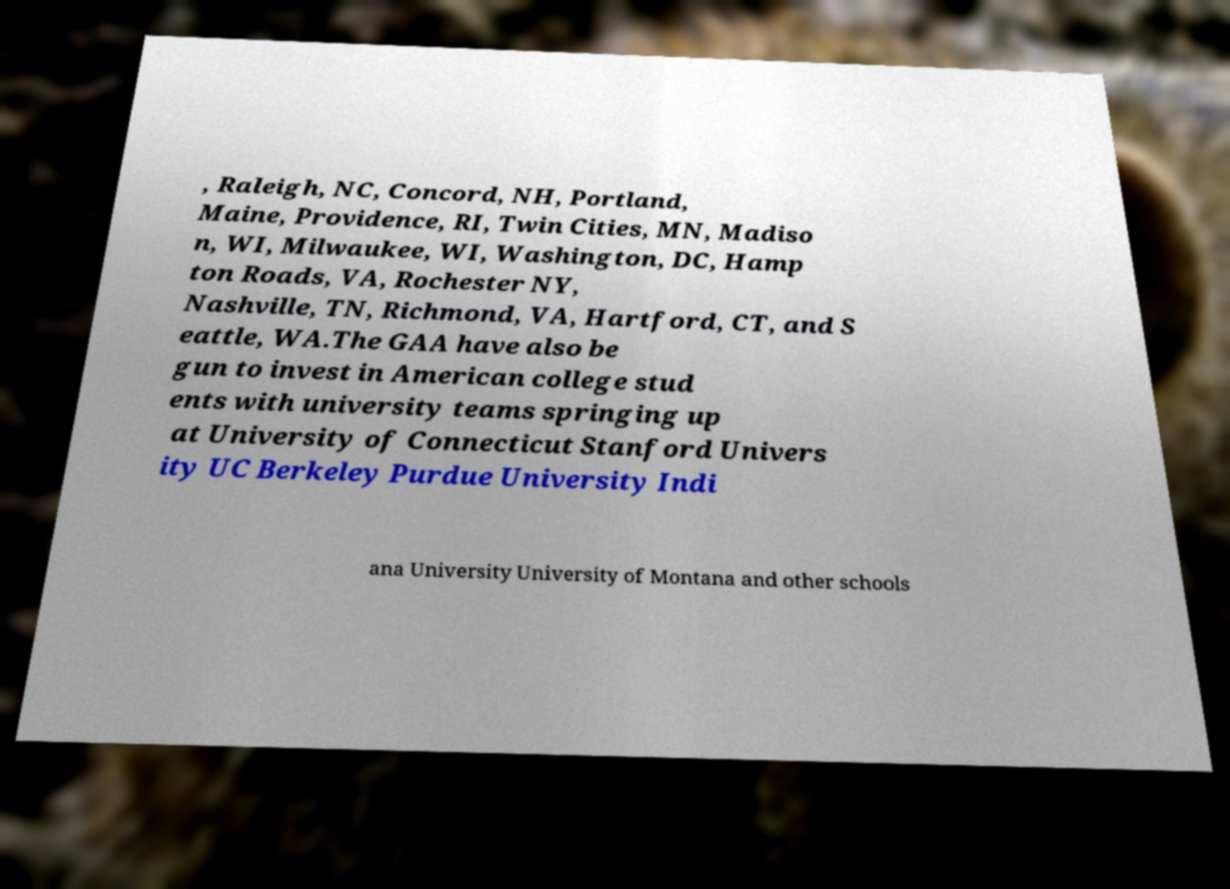There's text embedded in this image that I need extracted. Can you transcribe it verbatim? , Raleigh, NC, Concord, NH, Portland, Maine, Providence, RI, Twin Cities, MN, Madiso n, WI, Milwaukee, WI, Washington, DC, Hamp ton Roads, VA, Rochester NY, Nashville, TN, Richmond, VA, Hartford, CT, and S eattle, WA.The GAA have also be gun to invest in American college stud ents with university teams springing up at University of Connecticut Stanford Univers ity UC Berkeley Purdue University Indi ana University University of Montana and other schools 